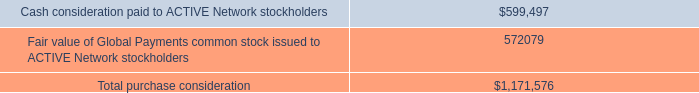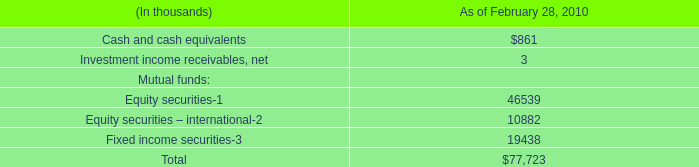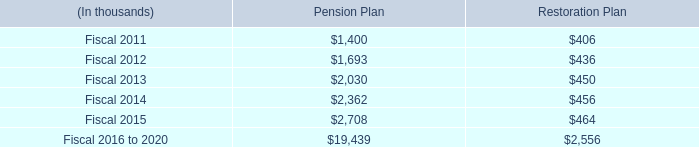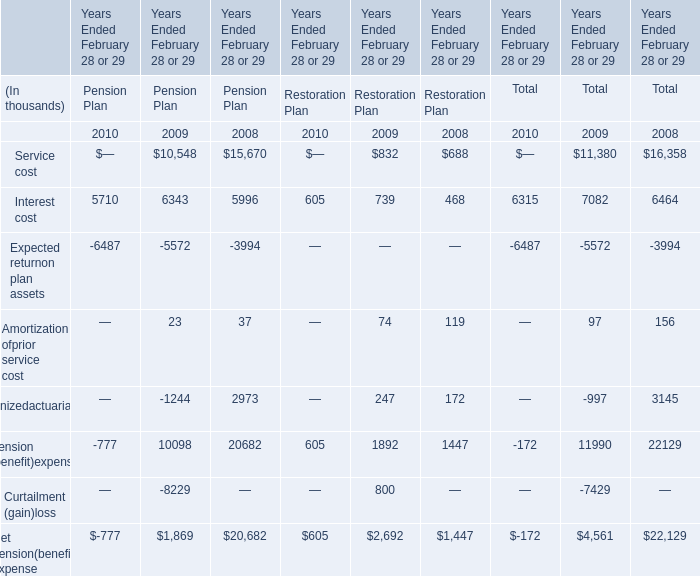In what year is Amortization ofprior service cost greater than 90? 
Answer: 2008,2009. 